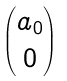Convert formula to latex. <formula><loc_0><loc_0><loc_500><loc_500>\begin{pmatrix} a _ { 0 } \\ { 0 } \end{pmatrix}</formula> 